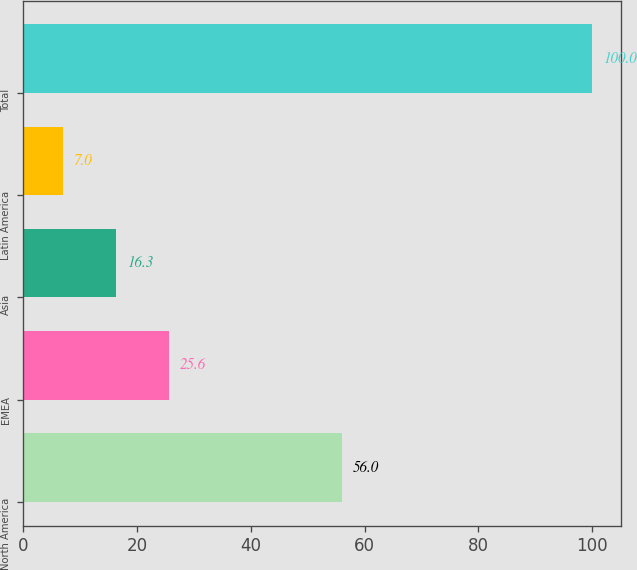Convert chart to OTSL. <chart><loc_0><loc_0><loc_500><loc_500><bar_chart><fcel>North America<fcel>EMEA<fcel>Asia<fcel>Latin America<fcel>Total<nl><fcel>56<fcel>25.6<fcel>16.3<fcel>7<fcel>100<nl></chart> 